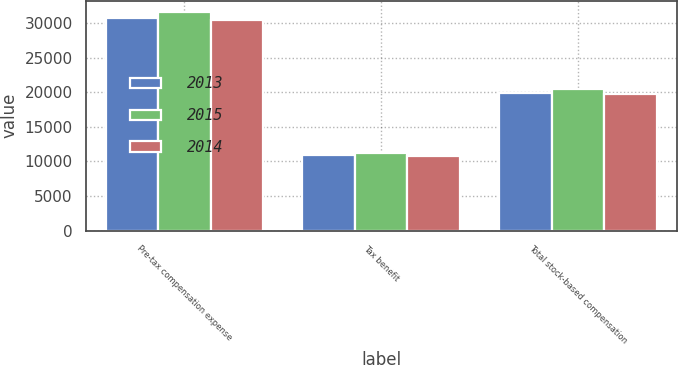Convert chart to OTSL. <chart><loc_0><loc_0><loc_500><loc_500><stacked_bar_chart><ecel><fcel>Pre-tax compensation expense<fcel>Tax benefit<fcel>Total stock-based compensation<nl><fcel>2013<fcel>30697<fcel>10877<fcel>19820<nl><fcel>2015<fcel>31628<fcel>11201<fcel>20427<nl><fcel>2014<fcel>30480<fcel>10745<fcel>19735<nl></chart> 